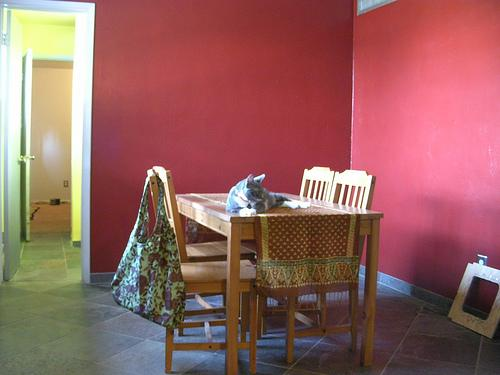What is the primary focus in the image, and what is it resting on? The primary focus in the image is a gray cat with white feet, and it is resting on a wooden dining room table. Can you describe the colors and pattern of the bag hanging on the chair in the image? The bag has a green, pink, and brown floral pattern. Please identify the color of the walls and the type of flooring in the dining room. The walls are red-painted and the flooring is grey-tiled in the dining room. How many main subjects are in the image, and what are they doing? There are two main subjects in the image, a gray cat resting on a wooden dining room table and a floral bag hanging on a chair. Describe the interaction between the cat and any other objects in the image. The cat is resting on a dining room table with a wooden runner, and it is not directly interacting with any other objects. What are three distinct objects or elements found in the image? Three distinct objects in the image include a gray cat on a table, a floral bag hanging on a chair, and an outlet in the wall. Describe the general ambiance and mood of the dining room image. The dining room has a warm and cozy atmosphere, with red painted walls, wooden furniture, and a grey tiled floor. What is the overall quality of the image in terms of clarity and composition? The image is of good quality, with a clear focus on the cat and various elements in the dining room, creating a visually pleasing composition. How many chairs can be seen around the wooden dining room table in the image? There are several light brown wooden chairs around the wooden dining room table. List the different textures and materials present in the image. Wood (table and chairs), fabric (bag and table cloth), paint (walls), tiles (floor), and fur (cat). 